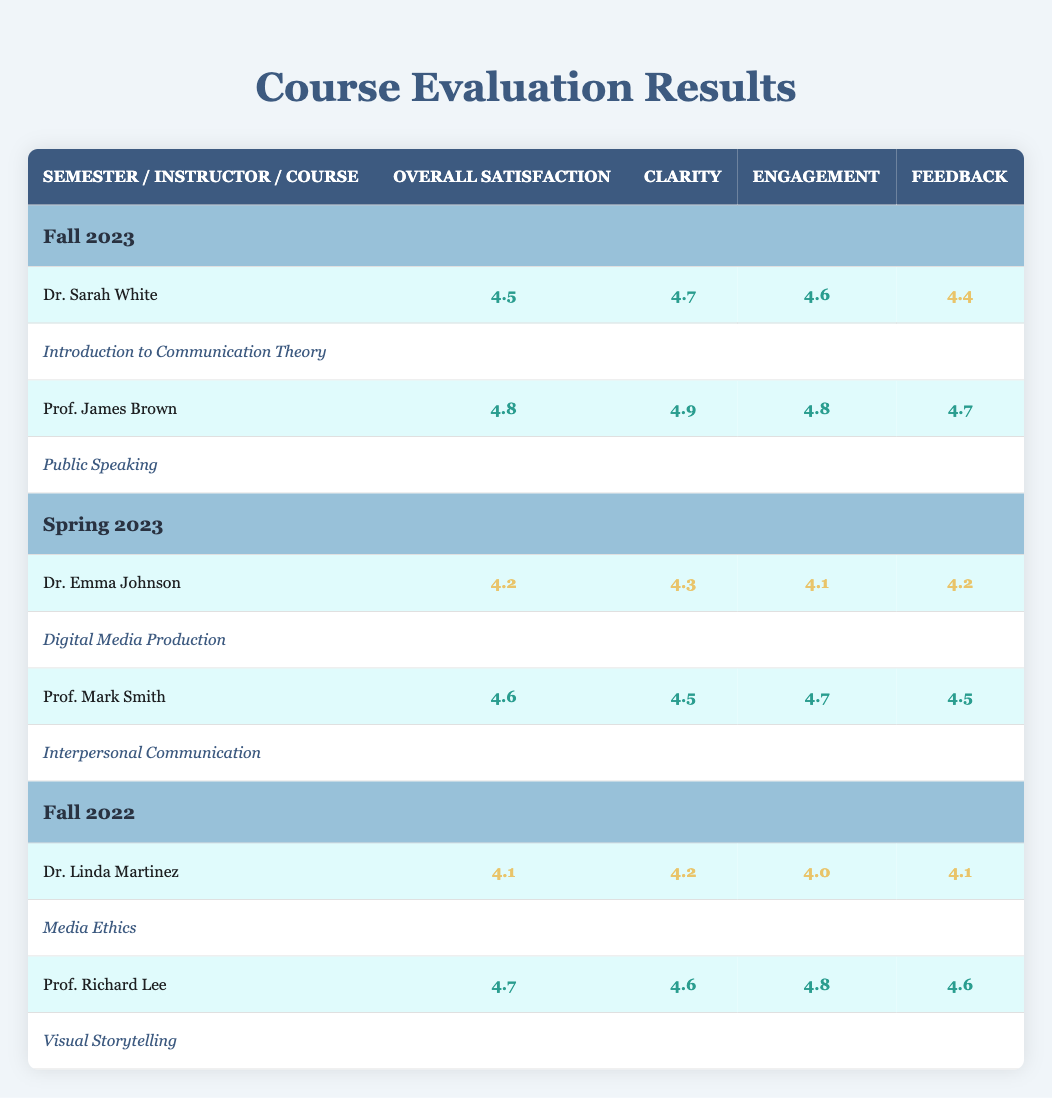What is the overall satisfaction score for Prof. James Brown in Fall 2023? The table shows that Prof. James Brown has an overall satisfaction score of 4.8 in the Fall 2023 semester.
Answer: 4.8 Which course taught by Dr. Emma Johnson had the lowest engagement score? Dr. Emma Johnson taught the course "Digital Media Production" with an engagement score of 4.1, which is the lowest for this instructor.
Answer: 4.1 True or False: Dr. Linda Martinez's clarity score was higher than her overall satisfaction score. Dr. Linda Martinez's clarity score is 4.2, while her overall satisfaction score is 4.1. Since 4.2 > 4.1, the statement is true.
Answer: True What is the average overall satisfaction score across all instructors for Fall 2022? The overall satisfaction scores for Fall 2022 are 4.1 (Dr. Linda Martinez) and 4.7 (Prof. Richard Lee). Summing these gives 4.1 + 4.7 = 8.8. To find the average, we divide by 2 (the number of instructors), so 8.8 / 2 = 4.4.
Answer: 4.4 Which instructor had the highest feedback score in Spring 2023? In Spring 2023, Prof. Mark Smith had the highest feedback score at 4.5, while Dr. Emma Johnson's feedback was 4.2. Therefore, Prof. Mark Smith had the highest score.
Answer: Prof. Mark Smith What is the difference between the engagement scores of Prof. Richard Lee and Dr. Sarah White? Prof. Richard Lee has an engagement score of 4.8 and Dr. Sarah White has a score of 4.6. The difference is calculated as 4.8 - 4.6 = 0.2.
Answer: 0.2 How many instructors had an overall satisfaction score of 4.5 or higher in Fall 2023? In Fall 2023, both instructors, Dr. Sarah White (4.5) and Prof. James Brown (4.8), had overall satisfaction scores of 4.5 or higher. Thus, there are 2 instructors.
Answer: 2 What was the average engagement score for all instructors in Fall 2023? The engagement scores for Fall 2023 are 4.6 (Dr. Sarah White) and 4.8 (Prof. James Brown). Adding these gives 4.6 + 4.8 = 9.4. Dividing by 2 gives the average: 9.4 / 2 = 4.7.
Answer: 4.7 